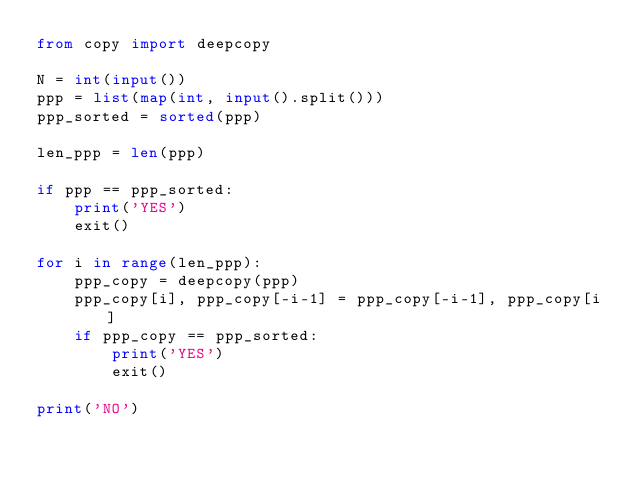<code> <loc_0><loc_0><loc_500><loc_500><_Python_>from copy import deepcopy

N = int(input())
ppp = list(map(int, input().split()))
ppp_sorted = sorted(ppp)

len_ppp = len(ppp)

if ppp == ppp_sorted:
    print('YES')
    exit()

for i in range(len_ppp):
    ppp_copy = deepcopy(ppp)
    ppp_copy[i], ppp_copy[-i-1] = ppp_copy[-i-1], ppp_copy[i]
    if ppp_copy == ppp_sorted:
        print('YES')
        exit()

print('NO')
</code> 